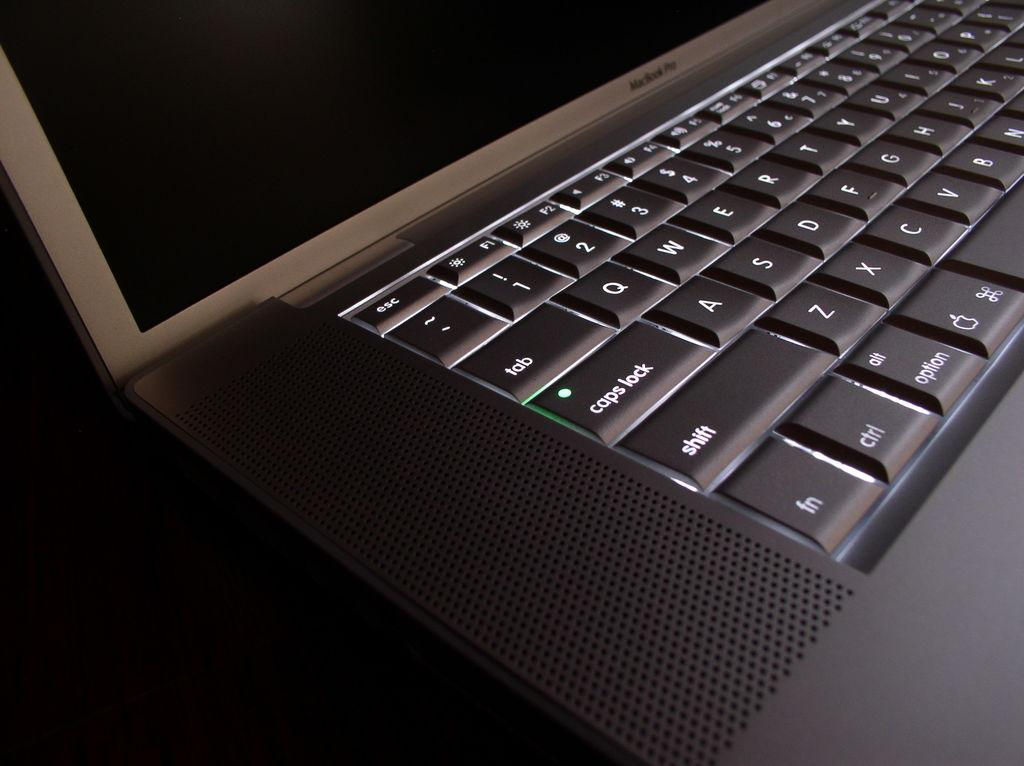<image>
Present a compact description of the photo's key features. A laptop has a keyboard with the green light lite up on the caps lock key. 